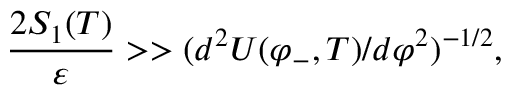Convert formula to latex. <formula><loc_0><loc_0><loc_500><loc_500>{ \frac { 2 S _ { 1 } ( T ) } { \varepsilon } } > > ( d ^ { 2 } { U ( \varphi _ { - } , T ) } / d \varphi ^ { 2 } ) ^ { - 1 / 2 } ,</formula> 